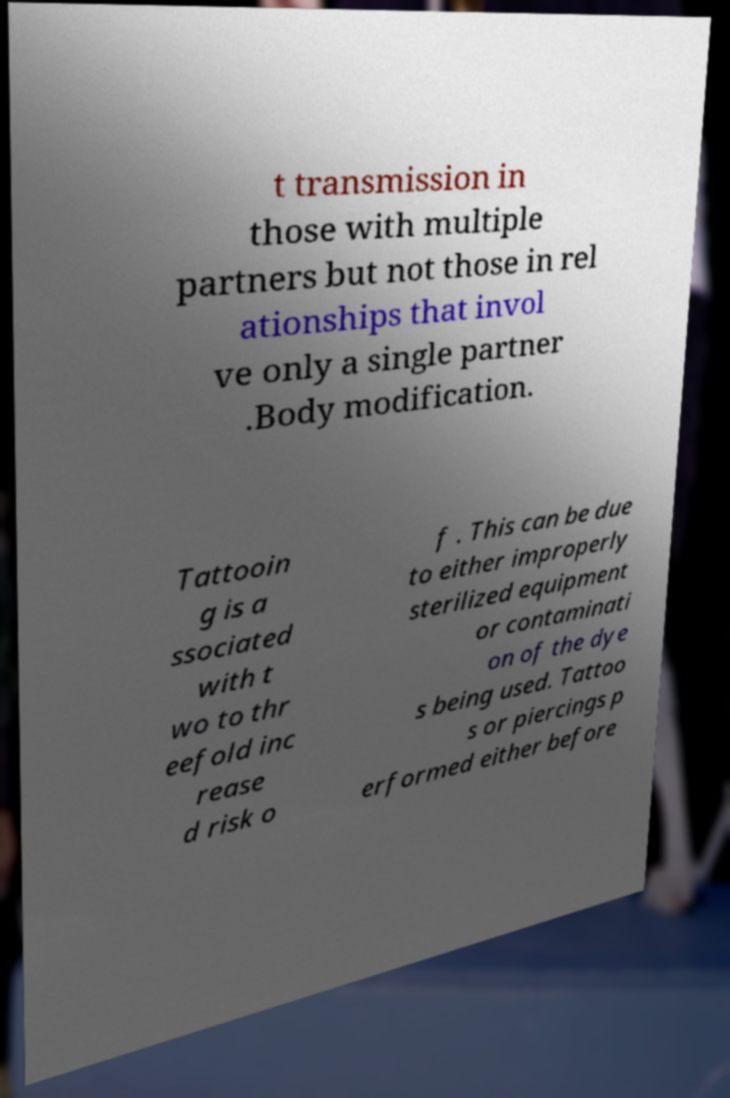Please read and relay the text visible in this image. What does it say? t transmission in those with multiple partners but not those in rel ationships that invol ve only a single partner .Body modification. Tattooin g is a ssociated with t wo to thr eefold inc rease d risk o f . This can be due to either improperly sterilized equipment or contaminati on of the dye s being used. Tattoo s or piercings p erformed either before 